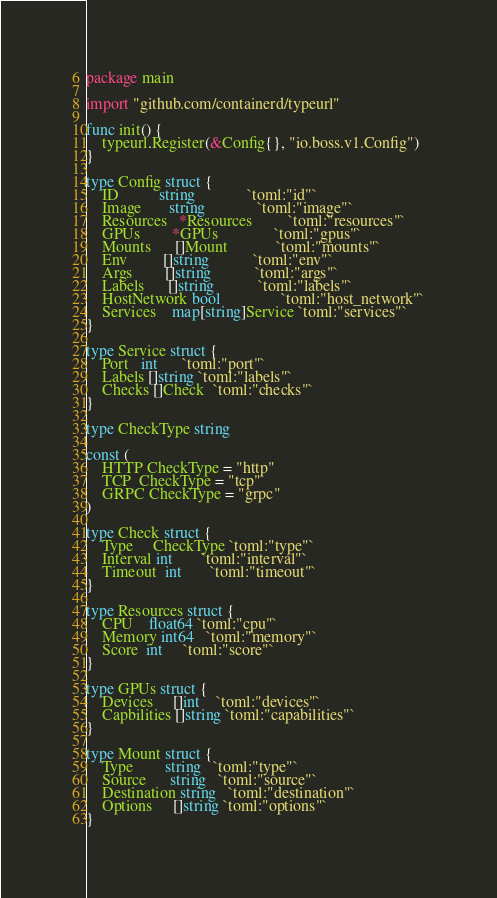<code> <loc_0><loc_0><loc_500><loc_500><_Go_>package main

import "github.com/containerd/typeurl"

func init() {
	typeurl.Register(&Config{}, "io.boss.v1.Config")
}

type Config struct {
	ID          string             `toml:"id"`
	Image       string             `toml:"image"`
	Resources   *Resources         `toml:"resources"`
	GPUs        *GPUs              `toml:"gpus"`
	Mounts      []Mount            `toml:"mounts"`
	Env         []string           `toml:"env"`
	Args        []string           `toml:"args"`
	Labels      []string           `toml:"labels"`
	HostNetwork bool               `toml:"host_network"`
	Services    map[string]Service `toml:"services"`
}

type Service struct {
	Port   int      `toml:"port"`
	Labels []string `toml:"labels"`
	Checks []Check  `toml:"checks"`
}

type CheckType string

const (
	HTTP CheckType = "http"
	TCP  CheckType = "tcp"
	GRPC CheckType = "grpc"
)

type Check struct {
	Type     CheckType `toml:"type"`
	Interval int       `toml:"interval"`
	Timeout  int       `toml:"timeout"`
}

type Resources struct {
	CPU    float64 `toml:"cpu"`
	Memory int64   `toml:"memory"`
	Score  int     `toml:"score"`
}

type GPUs struct {
	Devices     []int    `toml:"devices"`
	Capbilities []string `toml:"capabilities"`
}

type Mount struct {
	Type        string   `toml:"type"`
	Source      string   `toml:"source"`
	Destination string   `toml:"destination"`
	Options     []string `toml:"options"`
}
</code> 